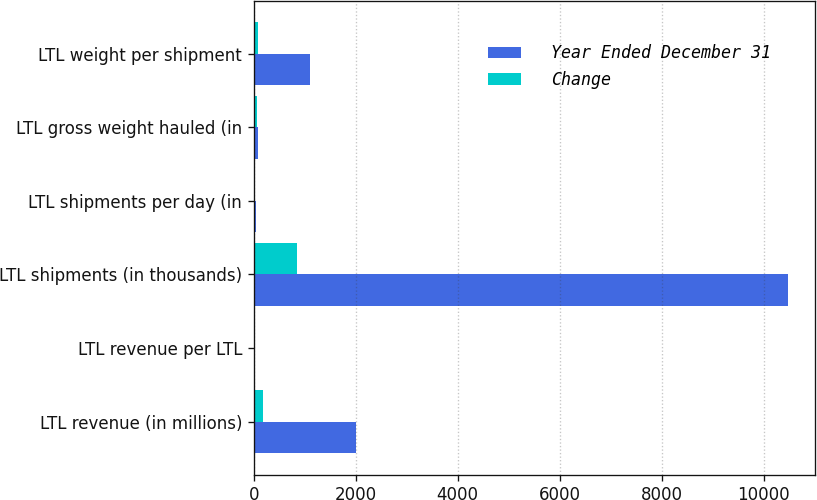Convert chart. <chart><loc_0><loc_0><loc_500><loc_500><stacked_bar_chart><ecel><fcel>LTL revenue (in millions)<fcel>LTL revenue per LTL<fcel>LTL shipments (in thousands)<fcel>LTL shipments per day (in<fcel>LTL gross weight hauled (in<fcel>LTL weight per shipment<nl><fcel>Year Ended December 31<fcel>2013<fcel>17.41<fcel>10481<fcel>41.4<fcel>90<fcel>1103<nl><fcel>Change<fcel>182<fcel>1.48<fcel>843<fcel>3.2<fcel>62<fcel>90<nl></chart> 